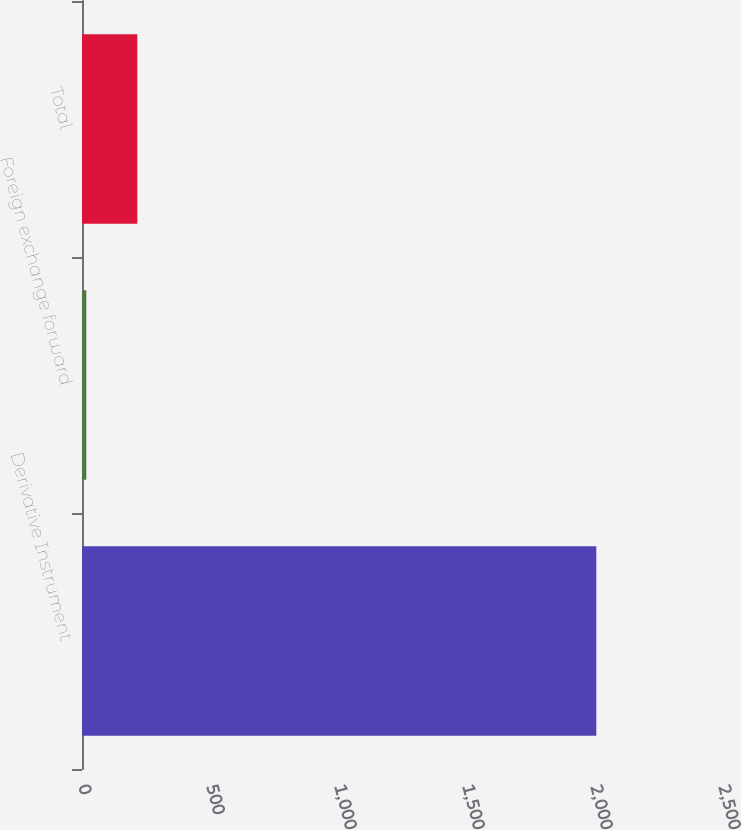Convert chart to OTSL. <chart><loc_0><loc_0><loc_500><loc_500><bar_chart><fcel>Derivative Instrument<fcel>Foreign exchange forward<fcel>Total<nl><fcel>2009<fcel>16.8<fcel>216.02<nl></chart> 